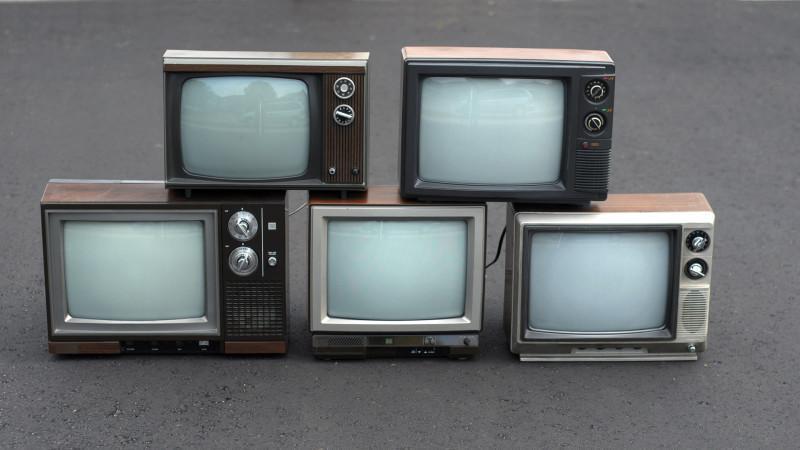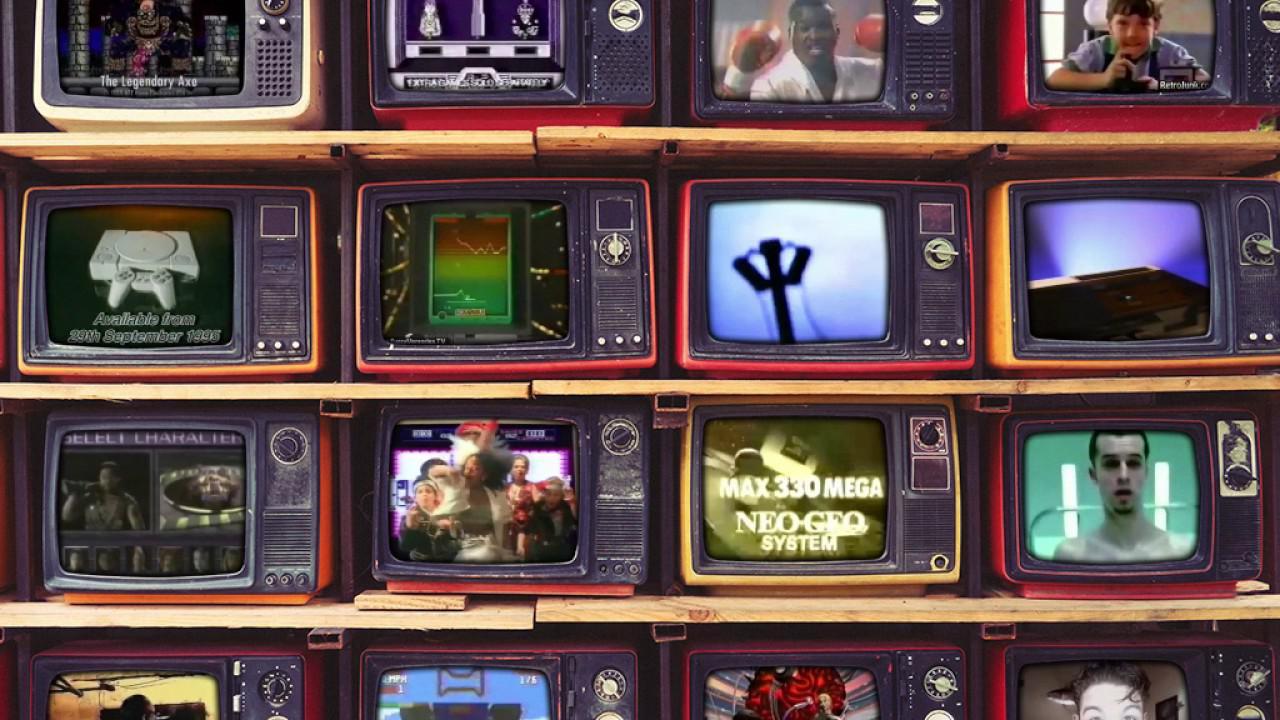The first image is the image on the left, the second image is the image on the right. Considering the images on both sides, is "The televisions in the left image appear to be powered on." valid? Answer yes or no. No. 